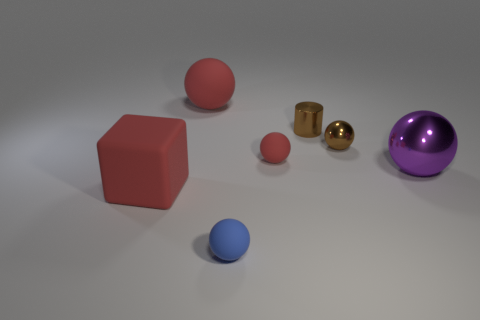What can you tell me about the lighting in the scene? The lighting in the scene appears to be coming from above, casting subtle shadows directly beneath the objects. It gives the objects a soft appearance and contributes to the reflections seen on the glossy surfaces. 